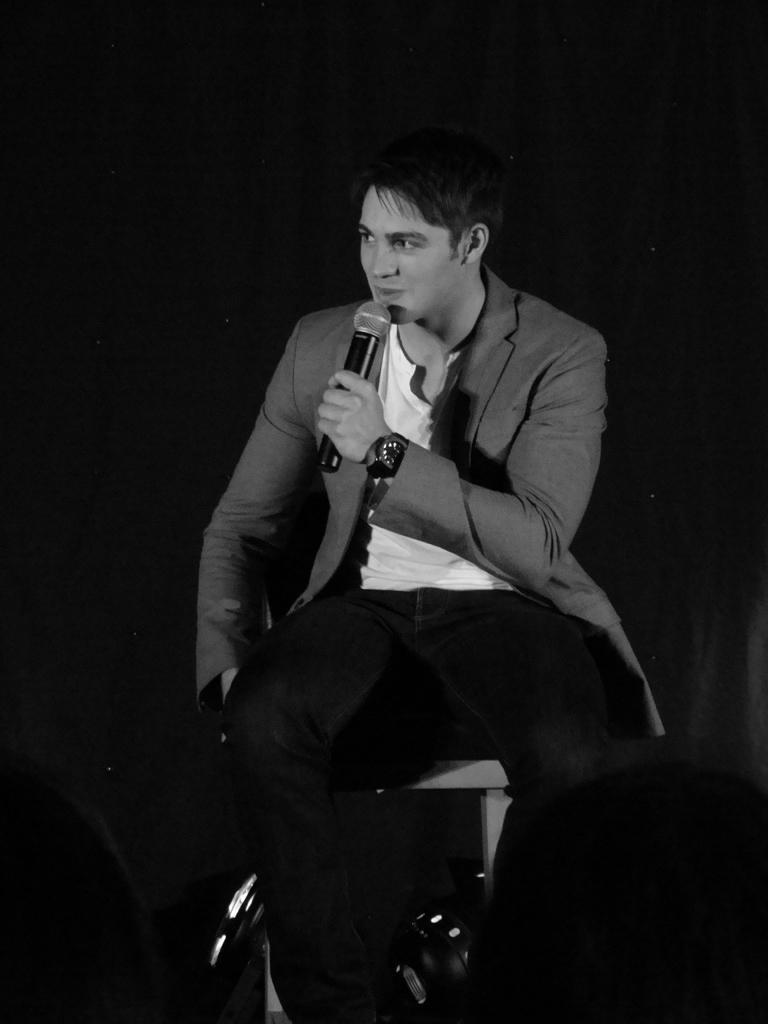In one or two sentences, can you explain what this image depicts? In the center we can see one man is sitting and holding microphone and he is smiling. 